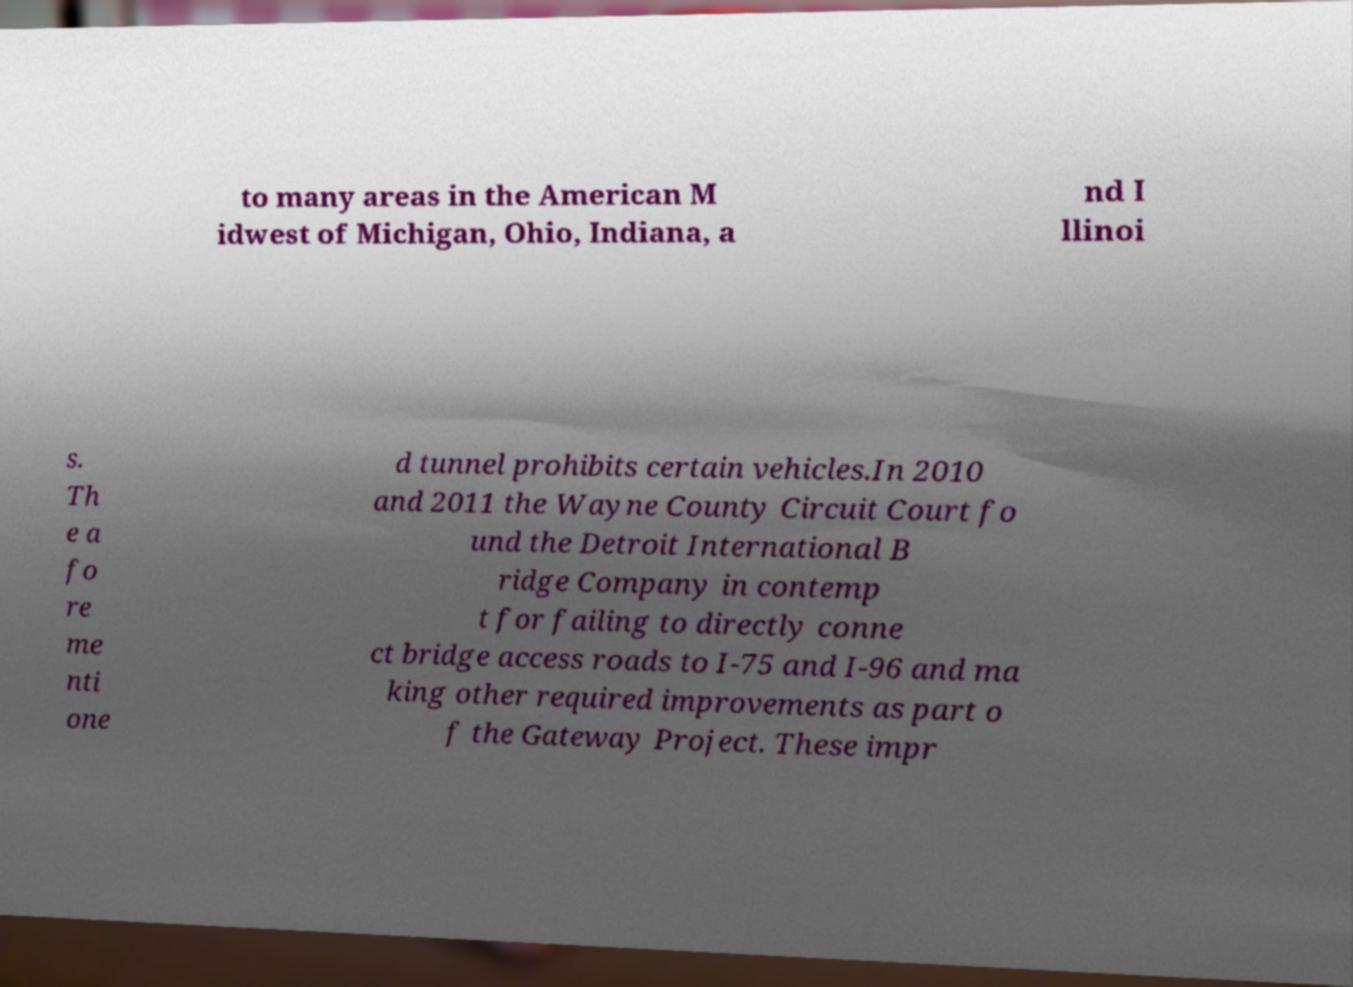What messages or text are displayed in this image? I need them in a readable, typed format. to many areas in the American M idwest of Michigan, Ohio, Indiana, a nd I llinoi s. Th e a fo re me nti one d tunnel prohibits certain vehicles.In 2010 and 2011 the Wayne County Circuit Court fo und the Detroit International B ridge Company in contemp t for failing to directly conne ct bridge access roads to I-75 and I-96 and ma king other required improvements as part o f the Gateway Project. These impr 